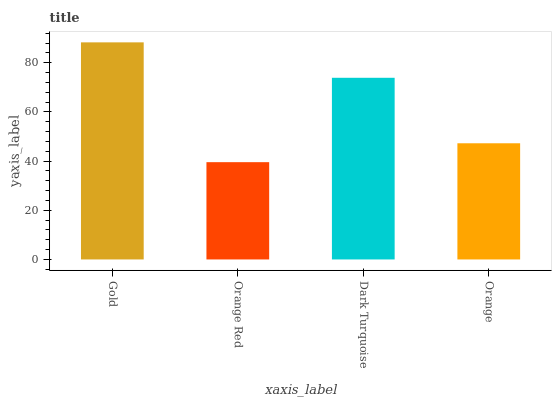Is Orange Red the minimum?
Answer yes or no. Yes. Is Gold the maximum?
Answer yes or no. Yes. Is Dark Turquoise the minimum?
Answer yes or no. No. Is Dark Turquoise the maximum?
Answer yes or no. No. Is Dark Turquoise greater than Orange Red?
Answer yes or no. Yes. Is Orange Red less than Dark Turquoise?
Answer yes or no. Yes. Is Orange Red greater than Dark Turquoise?
Answer yes or no. No. Is Dark Turquoise less than Orange Red?
Answer yes or no. No. Is Dark Turquoise the high median?
Answer yes or no. Yes. Is Orange the low median?
Answer yes or no. Yes. Is Orange the high median?
Answer yes or no. No. Is Orange Red the low median?
Answer yes or no. No. 